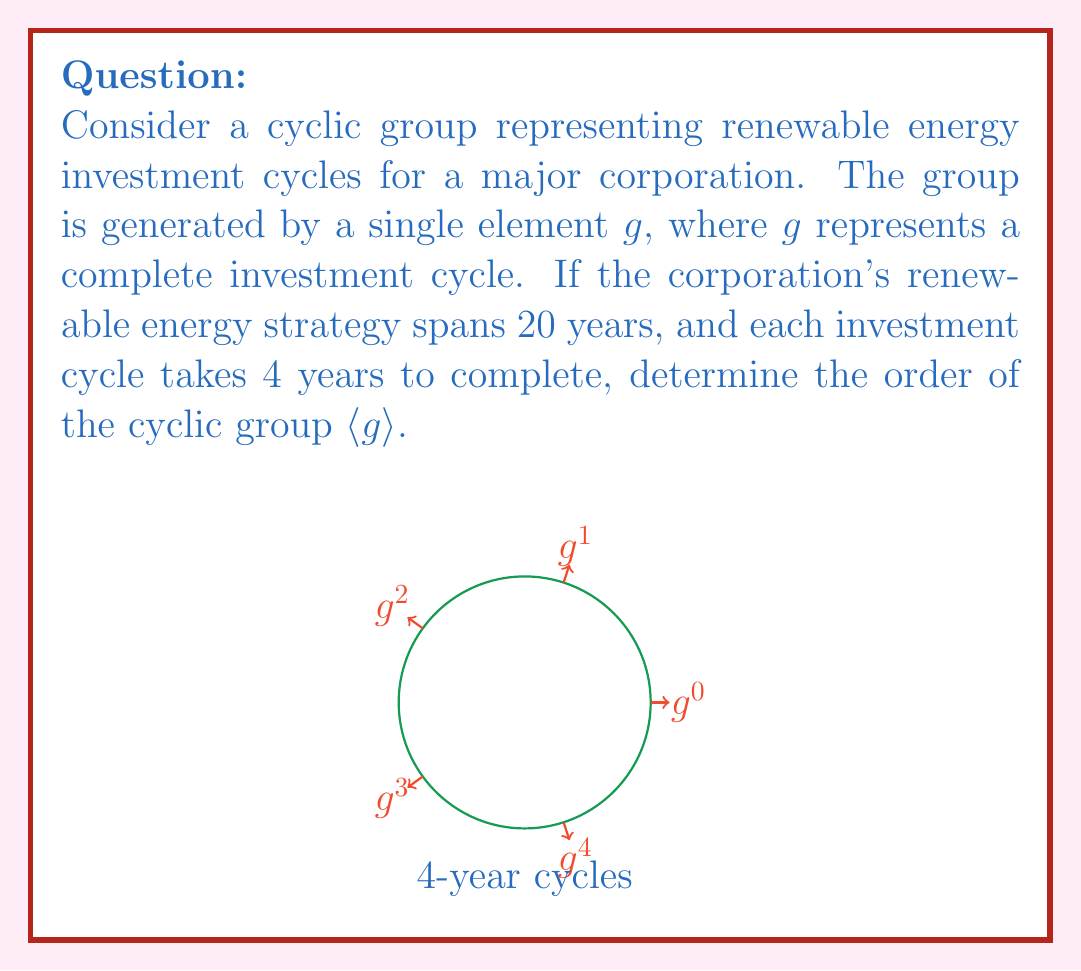Could you help me with this problem? To determine the order of the cyclic group, we need to follow these steps:

1) First, let's understand what the order of a cyclic group means. The order of a cyclic group is the smallest positive integer $n$ such that $g^n = e$, where $e$ is the identity element.

2) In this context, $g^n = e$ would mean that after $n$ investment cycles, we return to our starting point.

3) We're given that the corporation's renewable energy strategy spans 20 years.

4) Each investment cycle (represented by $g$) takes 4 years to complete.

5) To find how many complete cycles occur in 20 years, we divide:

   $$ \text{Number of cycles} = \frac{\text{Total strategy duration}}{\text{Duration of one cycle}} = \frac{20 \text{ years}}{4 \text{ years/cycle}} = 5 \text{ cycles} $$

6) This means that after 5 applications of $g$, we return to our starting point. In group theory notation:

   $$ g^5 = e $$

7) Therefore, the order of the cyclic group $\langle g \rangle$ is 5.
Answer: 5 